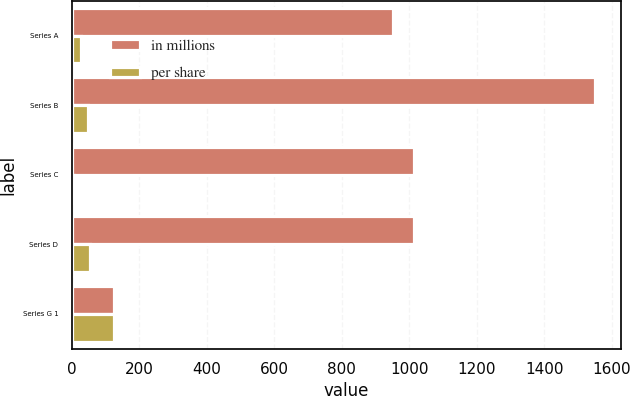Convert chart. <chart><loc_0><loc_0><loc_500><loc_500><stacked_bar_chart><ecel><fcel>Series A<fcel>Series B<fcel>Series C<fcel>Series D<fcel>Series G 1<nl><fcel>in millions<fcel>950.51<fcel>1550<fcel>1013.9<fcel>1013.9<fcel>125<nl><fcel>per share<fcel>28<fcel>50<fcel>8<fcel>55<fcel>125<nl></chart> 